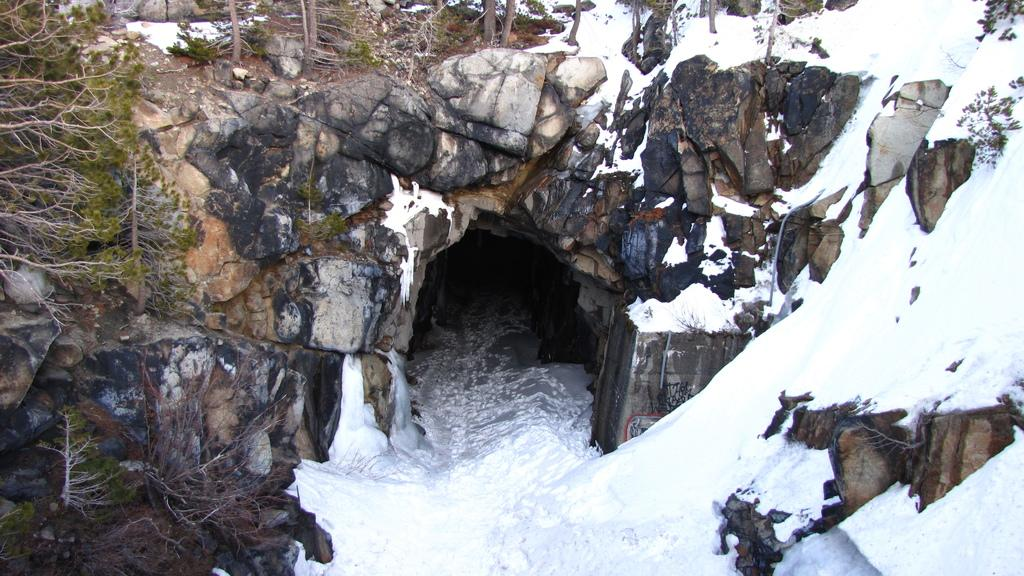What type of surface is visible in the image? There is a rock surface in the image. What is covering the rock surface? The rock surface is covered with snow. Is there any feature below the rock surface? Yes, there is a cave below the rock surface. How many oranges are visible on the rock surface in the image? There are no oranges visible on the rock surface in the image. Is there a basketball game taking place on the rock surface in the image? There is no basketball game taking place on the rock surface in the image. 